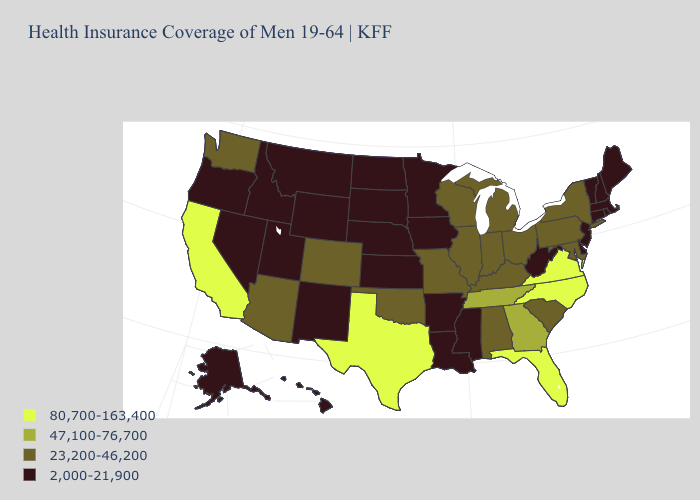Among the states that border Virginia , which have the highest value?
Answer briefly. North Carolina. Name the states that have a value in the range 23,200-46,200?
Write a very short answer. Alabama, Arizona, Colorado, Illinois, Indiana, Kentucky, Maryland, Michigan, Missouri, New York, Ohio, Oklahoma, Pennsylvania, South Carolina, Washington, Wisconsin. Which states hav the highest value in the South?
Be succinct. Florida, North Carolina, Texas, Virginia. Which states have the highest value in the USA?
Short answer required. California, Florida, North Carolina, Texas, Virginia. Which states have the highest value in the USA?
Be succinct. California, Florida, North Carolina, Texas, Virginia. Name the states that have a value in the range 47,100-76,700?
Keep it brief. Georgia, Tennessee. What is the value of Idaho?
Be succinct. 2,000-21,900. What is the highest value in states that border New Jersey?
Quick response, please. 23,200-46,200. What is the highest value in states that border South Dakota?
Keep it brief. 2,000-21,900. What is the highest value in the South ?
Answer briefly. 80,700-163,400. What is the highest value in the USA?
Answer briefly. 80,700-163,400. What is the highest value in the USA?
Concise answer only. 80,700-163,400. What is the value of Wyoming?
Answer briefly. 2,000-21,900. What is the lowest value in the USA?
Short answer required. 2,000-21,900. Which states have the lowest value in the USA?
Short answer required. Alaska, Arkansas, Connecticut, Delaware, Hawaii, Idaho, Iowa, Kansas, Louisiana, Maine, Massachusetts, Minnesota, Mississippi, Montana, Nebraska, Nevada, New Hampshire, New Jersey, New Mexico, North Dakota, Oregon, Rhode Island, South Dakota, Utah, Vermont, West Virginia, Wyoming. 